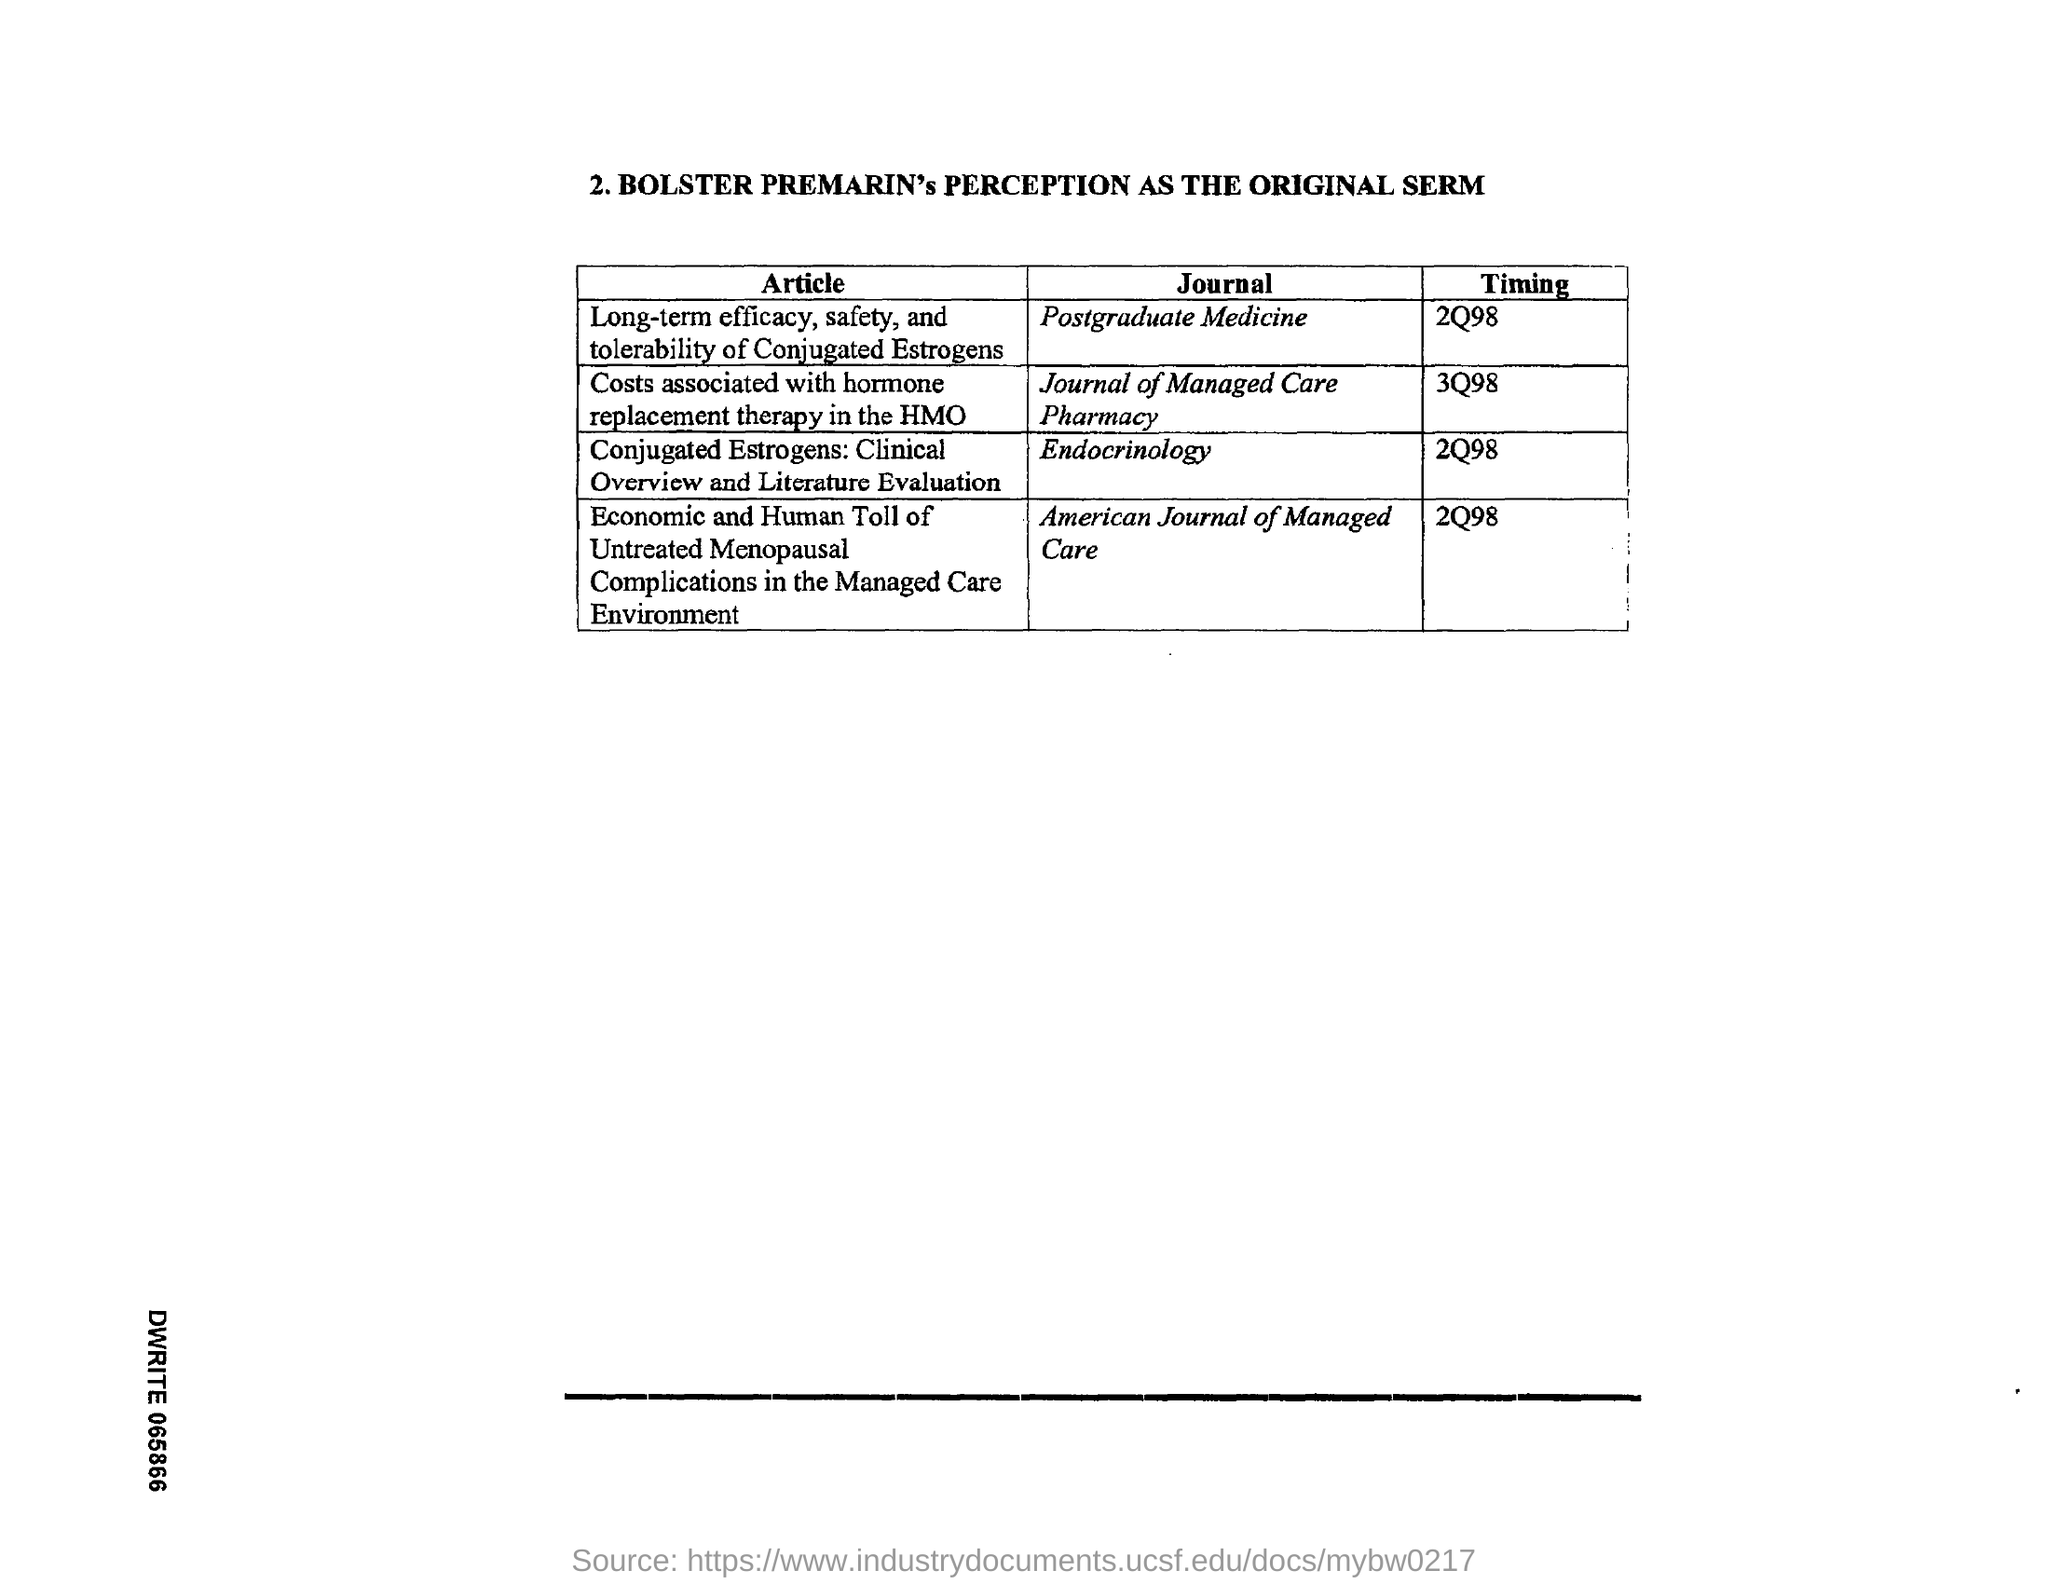What is the Timing for the Journal "Postgraduate Medicine"?
Your response must be concise. 2Q98. What is the Timing for the Journal "Journal of Managed Care Pharmacy"?
Keep it short and to the point. 3Q98. What is the Timing for the Journal "Endocrinology"?
Make the answer very short. 2Q98. What is the Timing for the Journal "American Journal of Managed Care"?
Ensure brevity in your answer.  2Q98. 